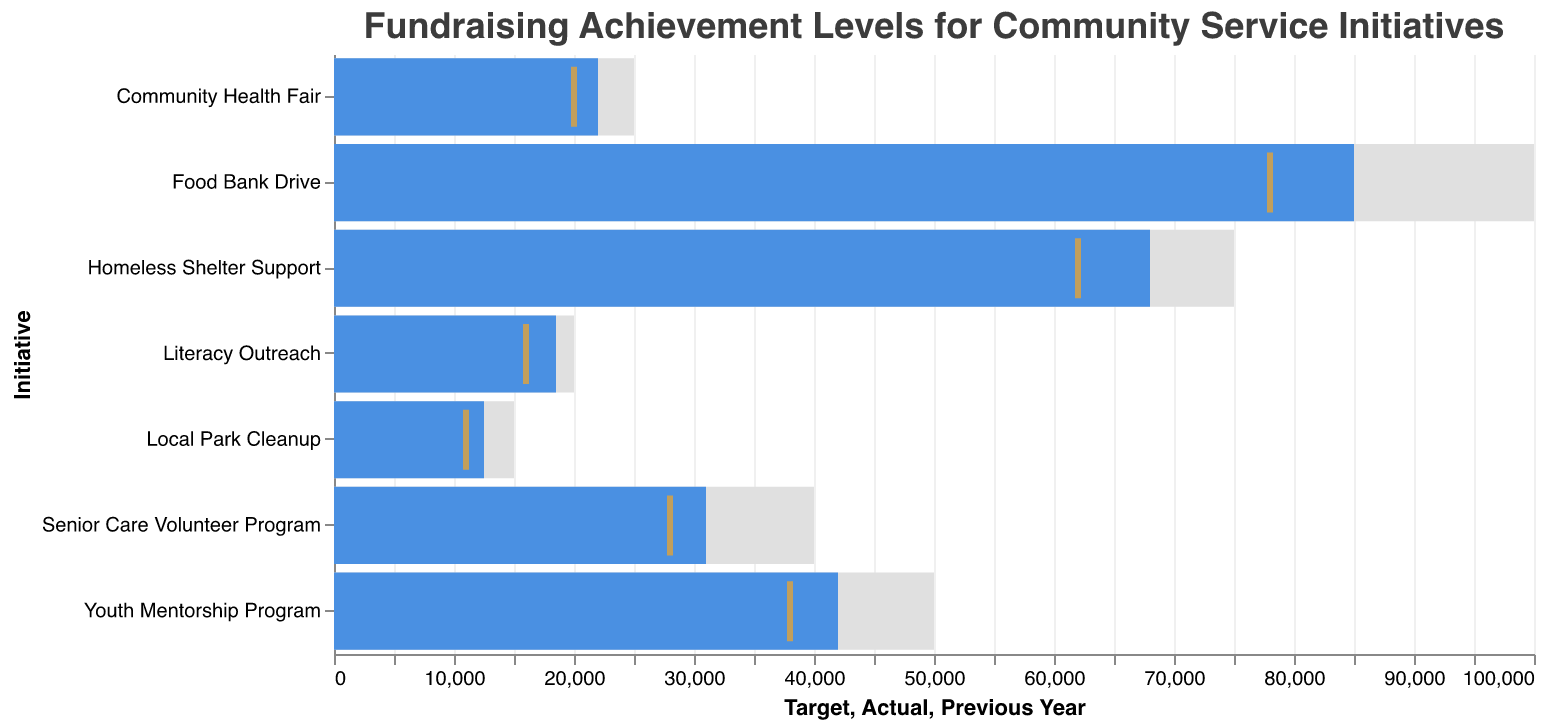What is the title of the chart? The title is the descriptive text at the top of the chart, which provides an overview of what the chart represents.
Answer: Fundraising Achievement Levels for Community Service Initiatives How many community service initiatives are displayed in the chart? Counting each unique initiative name on the y-axis gives the total number of initiatives displayed.
Answer: 7 Which initiative achieved the highest actual fundraising amount? Look for the initiative with the longest blue bar as it represents the actual fundraising amount.
Answer: Food Bank Drive What is the target fundraising amount for the Community Health Fair? Locate the Community Health Fair on the y-axis and read the corresponding target value along the x-axis, represented by the outer grey bar.
Answer: $25000 How much more did the Food Bank Drive raise compared to the previous year? Subtract the previous year's amount (yellow tick) from the actual amount (blue bar) for the Food Bank Drive initiative.
Answer: $7000 Which initiative has the lowest actual fundraising amount and what is it? Identify the shortest blue bar and read its value directly from the x-axis.
Answer: Local Park Cleanup, $12500 Did the Youth Mentorship Program meet its fundraising target? Compare the length of the blue bar (actual) with the length of the grey bar (target) for the Youth Mentorship Program.
Answer: No How does the actual amount raised for the Homeless Shelter Support compare to the previous year? Since the blue bar (actual) is longer than the yellow tick (previous year), compare these values directly.
Answer: The actual amount is higher What is the combined target fundraising amount for the Senior Care Volunteer Program and Literacy Outreach initiatives? Add the target amounts for both initiatives: $40000 (Senior Care Volunteer Program) + $20000 (Literacy Outreach).
Answer: $60000 Which initiative had the smallest increase in actual fundraising compared to the previous year? Calculate the difference between the actual and previous year amounts for each initiative and identify the smallest difference.
Answer: Community Health Fair, $2000 